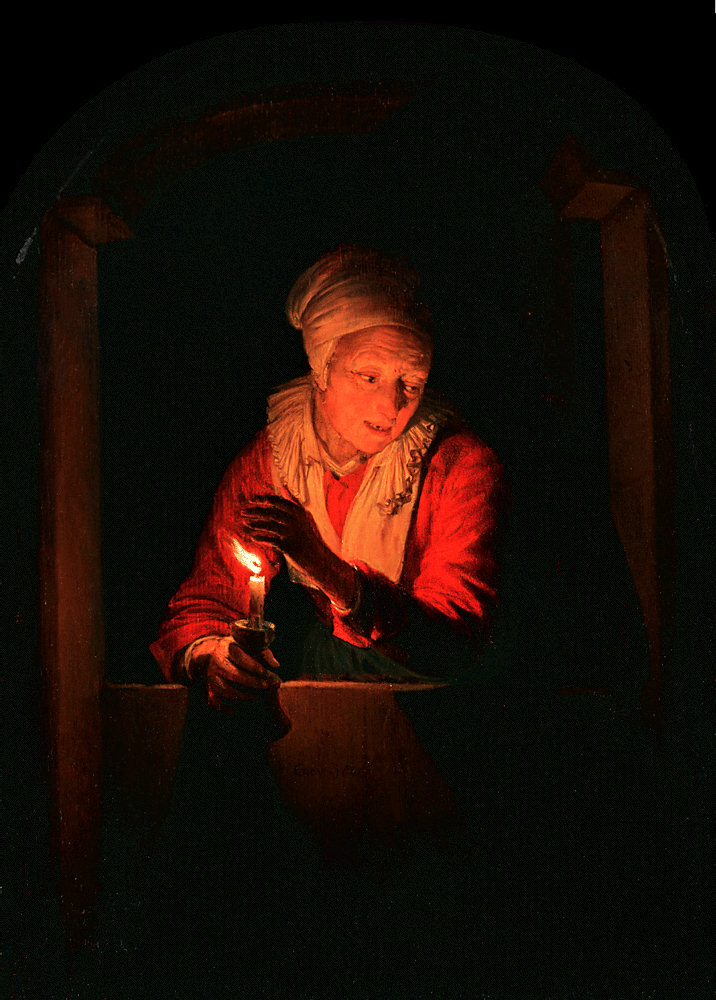Why is the woman in the painting alone? What's the larger story? The elderly woman in the painting, Elda, is alone because she has outlived her beloved family and friends. She now cherishes her solitude, finding comfort in the nightly ritual of lighting a candle that once brought her children to bed. This act keeps the memories of her loved ones alive, connecting her past to the present. Her life, filled with both joy and sorrow, has taught her the resilience of the human spirit, illuminating her path even in the darkest hours. 